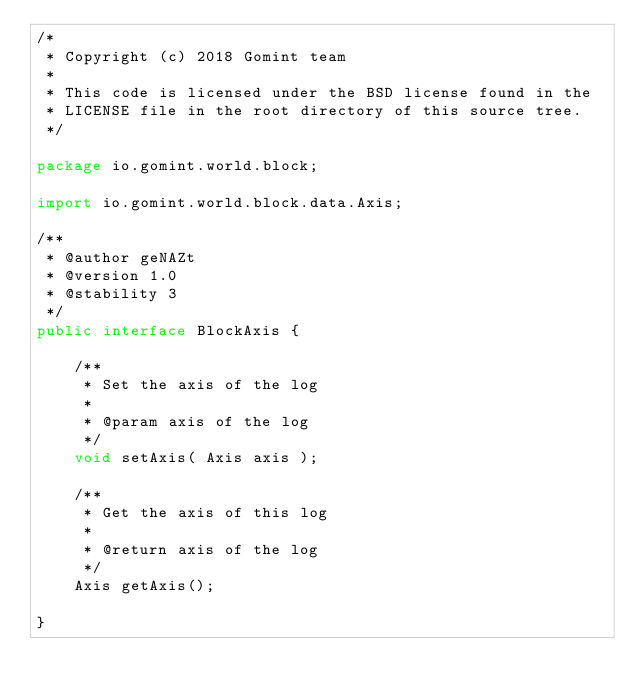<code> <loc_0><loc_0><loc_500><loc_500><_Java_>/*
 * Copyright (c) 2018 Gomint team
 *
 * This code is licensed under the BSD license found in the
 * LICENSE file in the root directory of this source tree.
 */

package io.gomint.world.block;

import io.gomint.world.block.data.Axis;

/**
 * @author geNAZt
 * @version 1.0
 * @stability 3
 */
public interface BlockAxis {

    /**
     * Set the axis of the log
     *
     * @param axis of the log
     */
    void setAxis( Axis axis );

    /**
     * Get the axis of this log
     *
     * @return axis of the log
     */
    Axis getAxis();

}
</code> 